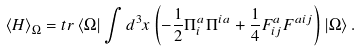Convert formula to latex. <formula><loc_0><loc_0><loc_500><loc_500>\left \langle H \right \rangle _ { \Omega } = t r \left \langle \Omega \right | \int { d ^ { 3 } x } \left ( { - \frac { 1 } { 2 } \Pi _ { i } ^ { a } \Pi ^ { i a } + \frac { 1 } { 4 } F _ { i j } ^ { a } F ^ { a i j } } \right ) \left | \Omega \right \rangle .</formula> 